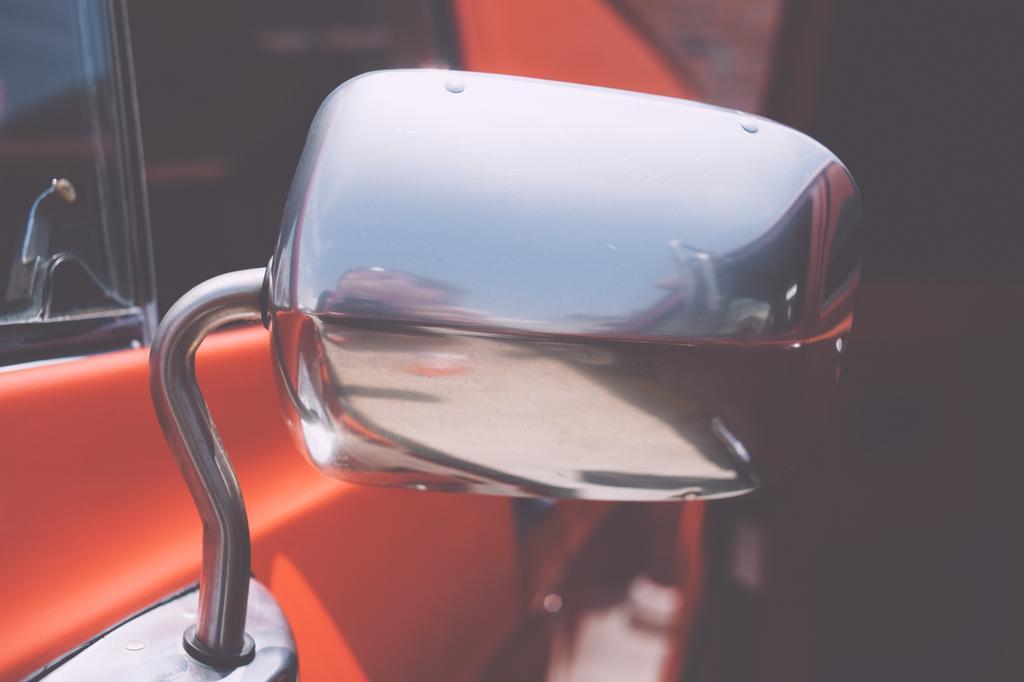Could you give a brief overview of what you see in this image? In the image there is a orange color car with a silver mirror. 